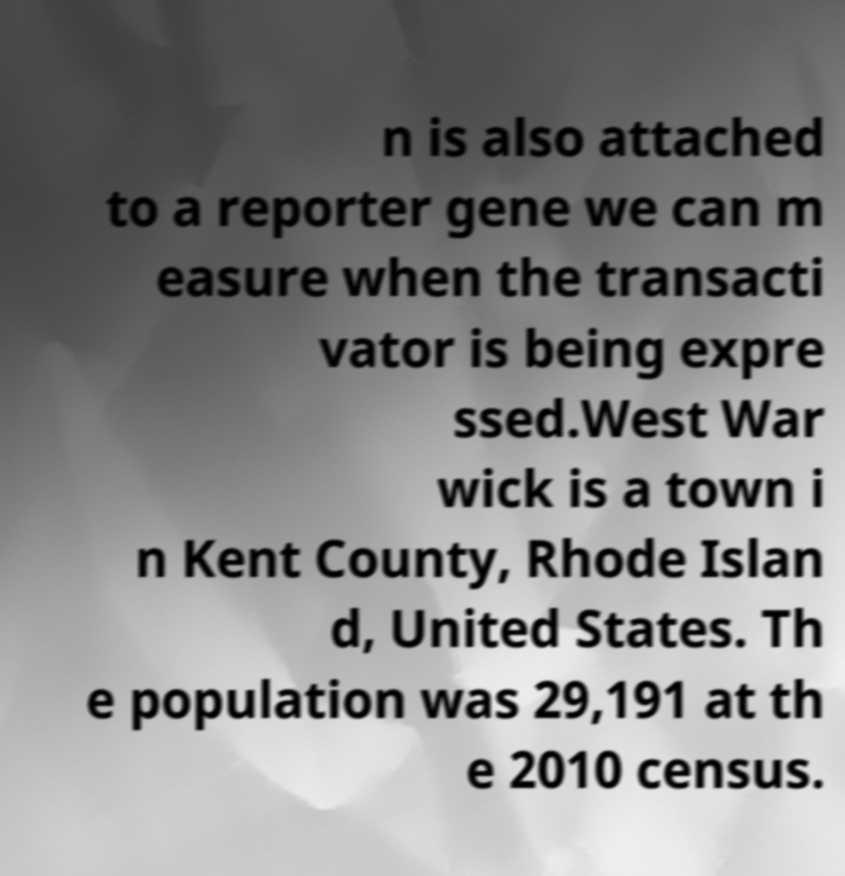Could you extract and type out the text from this image? n is also attached to a reporter gene we can m easure when the transacti vator is being expre ssed.West War wick is a town i n Kent County, Rhode Islan d, United States. Th e population was 29,191 at th e 2010 census. 